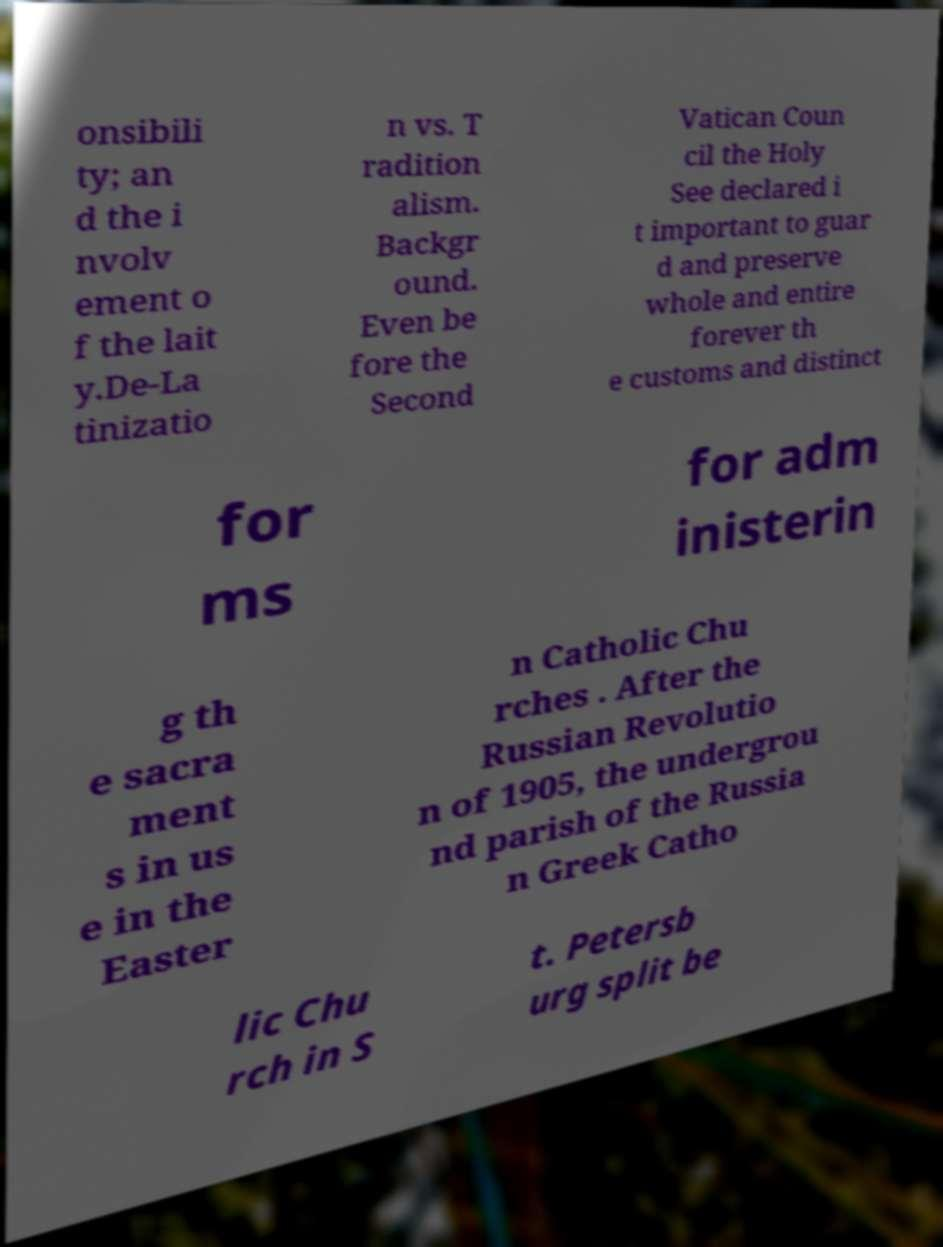Could you assist in decoding the text presented in this image and type it out clearly? onsibili ty; an d the i nvolv ement o f the lait y.De-La tinizatio n vs. T radition alism. Backgr ound. Even be fore the Second Vatican Coun cil the Holy See declared i t important to guar d and preserve whole and entire forever th e customs and distinct for ms for adm inisterin g th e sacra ment s in us e in the Easter n Catholic Chu rches . After the Russian Revolutio n of 1905, the undergrou nd parish of the Russia n Greek Catho lic Chu rch in S t. Petersb urg split be 